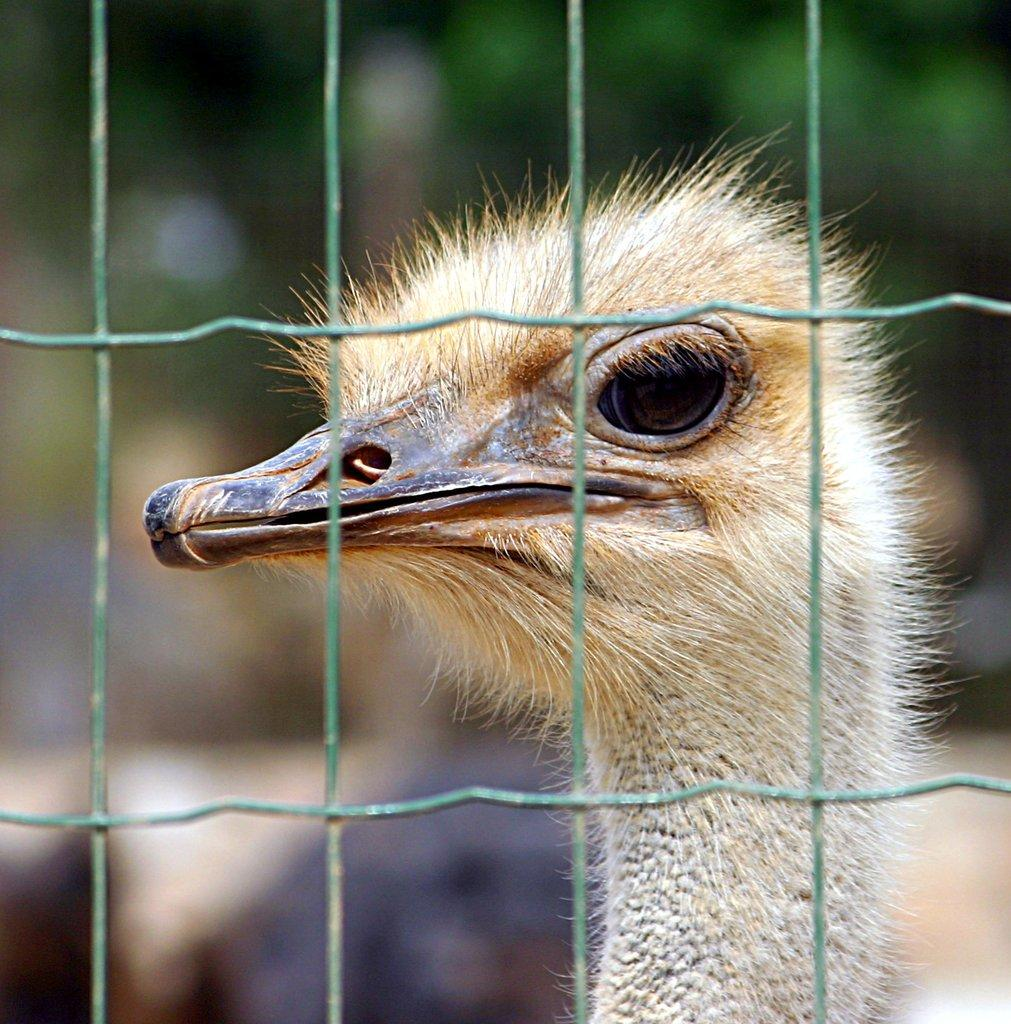What type of barrier is present in the image? There is a chain fence in the image. What can be seen behind the chain fence? An ostrich head is visible behind the fence. How would you describe the background of the image? The background of the image is blurred. Can you see any badges on the ostrich in the image? There are no badges visible on the ostrich in the image. Is there any indication of a birth or birth-related event in the image? There is no indication of a birth or birth-related event in the image. 